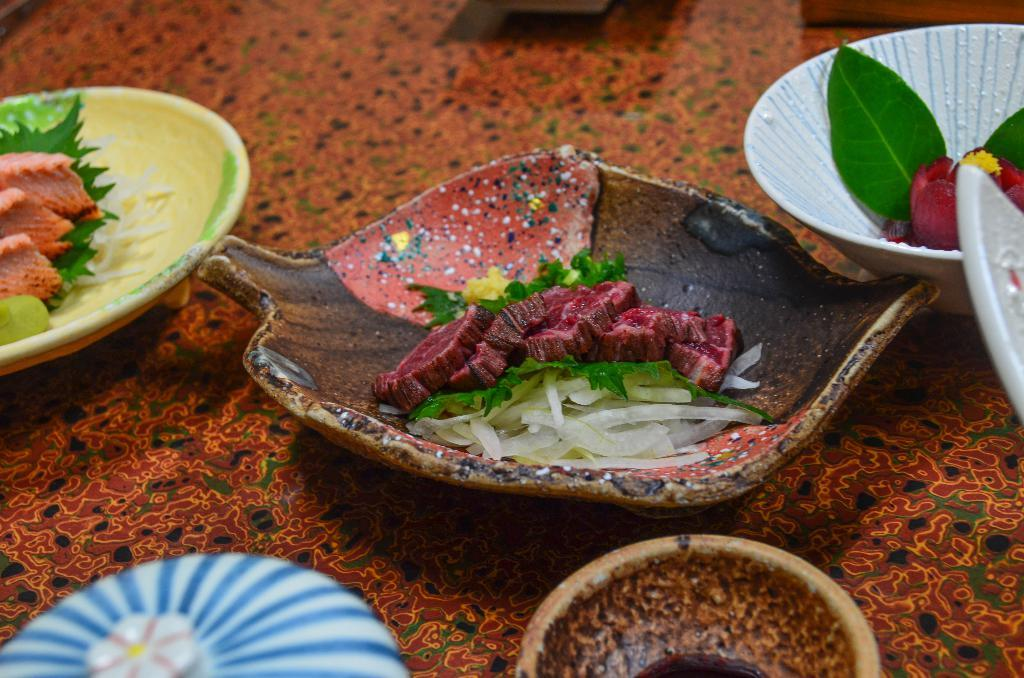What is in the bowl that is visible in the image? There are food items in a bowl. Where is the bowl located in the image? The bowl is placed on a table. What type of shock can be seen in the image? There is no shock present in the image; it features a bowl of food items placed on a table. What arithmetic problem is being solved in the image? There is no arithmetic problem present in the image; it features a bowl of food items placed on a table. 